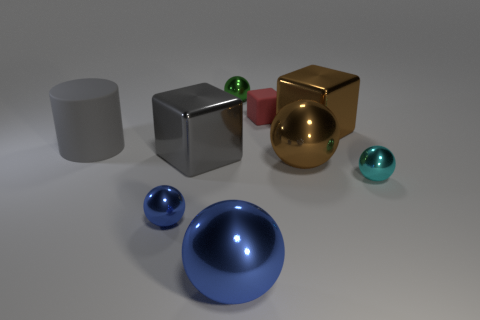Subtract all cyan metallic balls. How many balls are left? 4 Add 1 large brown metallic blocks. How many objects exist? 10 Subtract all gray cubes. How many cubes are left? 2 Subtract 0 purple spheres. How many objects are left? 9 Subtract all blocks. How many objects are left? 6 Subtract all blue cylinders. Subtract all blue balls. How many cylinders are left? 1 Subtract all blue balls. How many brown cubes are left? 1 Subtract all tiny cyan rubber objects. Subtract all large gray cylinders. How many objects are left? 8 Add 2 small green spheres. How many small green spheres are left? 3 Add 1 blue spheres. How many blue spheres exist? 3 